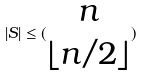Convert formula to latex. <formula><loc_0><loc_0><loc_500><loc_500>| S | \leq ( \begin{matrix} n \\ \lfloor n / 2 \rfloor \end{matrix} )</formula> 